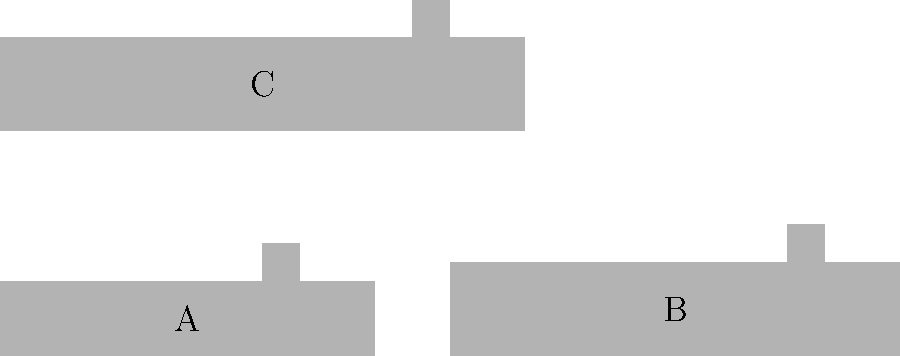Identify the submarine types A, B, and C based on their silhouettes. Which of these represents the Type XXI U-boat, known for its revolutionary design that influenced post-war submarine development? To identify the Type XXI U-boat and answer this question, let's analyze the characteristics of each silhouette:

1. Silhouette A:
   - Relatively small and compact design
   - Conning tower located closer to the center
   - This represents the Type VII U-boat, the most common German submarine in World War II

2. Silhouette B:
   - Longer and larger than Silhouette A
   - Conning tower positioned slightly forward of center
   - This represents the Type IX U-boat, designed for long-range operations

3. Silhouette C:
   - Sleek, streamlined hull design
   - Integrated conning tower with a rounded shape
   - Larger overall size compared to the other two silhouettes
   - This unique design represents the Type XXI U-boat

The Type XXI U-boat, also known as the "Elektroboot," was a revolutionary design introduced late in World War II. It featured:
- A streamlined hull for improved underwater performance
- Increased battery capacity for extended submerged operations
- Snorkel device for underwater diesel engine operation
- Advanced sonar and fire control systems

These features made the Type XXI U-boat far more capable than its predecessors and significantly influenced post-war submarine design in many nations.

Based on these characteristics, we can conclude that Silhouette C represents the Type XXI U-boat.
Answer: C 